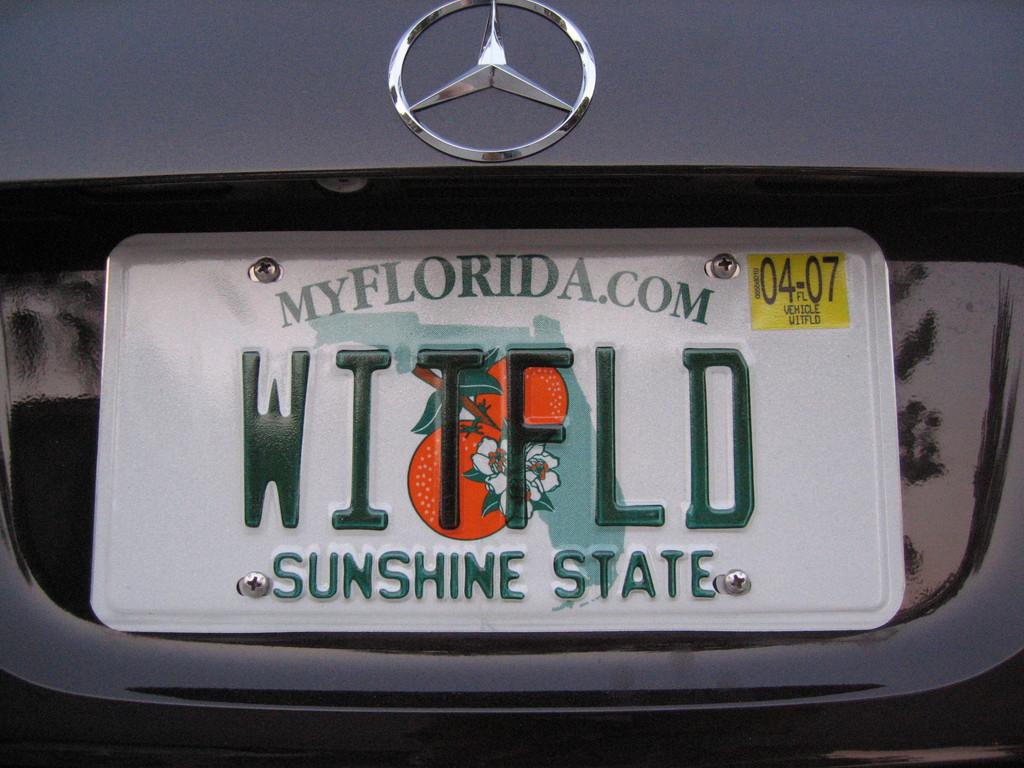What state is this license plate from?
Your answer should be very brief. Florida. 